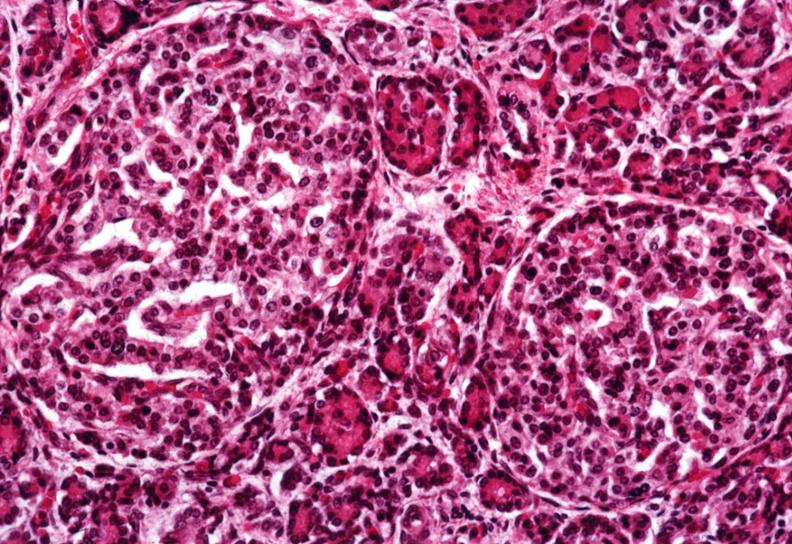does pneumocystis show two quite large islets?
Answer the question using a single word or phrase. No 